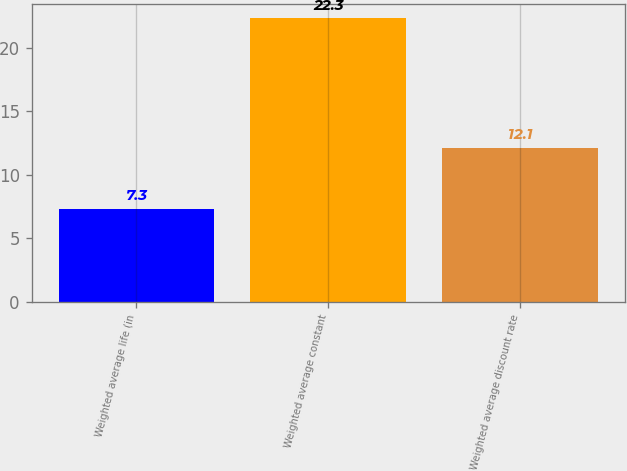Convert chart. <chart><loc_0><loc_0><loc_500><loc_500><bar_chart><fcel>Weighted average life (in<fcel>Weighted average constant<fcel>Weighted average discount rate<nl><fcel>7.3<fcel>22.3<fcel>12.1<nl></chart> 